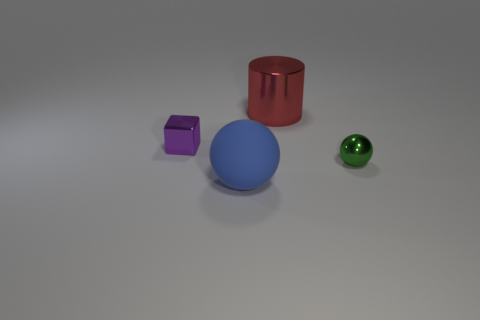What number of green objects are blocks or small balls?
Offer a terse response. 1. Are there fewer big blue matte objects that are behind the metal sphere than red rubber objects?
Give a very brief answer. No. The small object that is right of the small shiny object that is behind the metal thing on the right side of the big red thing is what color?
Provide a short and direct response. Green. Is there anything else that has the same material as the big ball?
Your answer should be very brief. No. There is another green thing that is the same shape as the matte object; what size is it?
Your response must be concise. Small. Is the number of red shiny objects in front of the purple shiny block less than the number of big blue balls that are behind the large rubber thing?
Offer a terse response. No. There is a object that is both right of the big blue matte ball and in front of the red metallic thing; what shape is it?
Give a very brief answer. Sphere. What size is the purple cube that is made of the same material as the tiny green object?
Provide a succinct answer. Small. There is a object that is behind the tiny green metal thing and on the right side of the tiny purple cube; what material is it?
Make the answer very short. Metal. There is a big object on the left side of the big red shiny cylinder; does it have the same shape as the small object that is to the right of the blue matte ball?
Make the answer very short. Yes. 